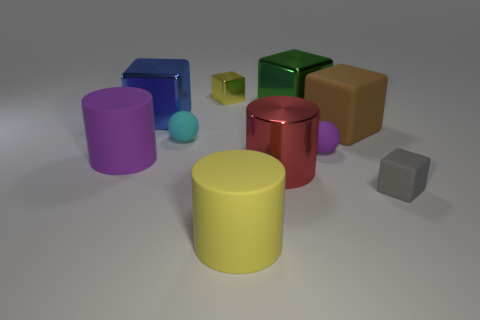What shape is the big metallic thing on the left side of the small cyan rubber thing that is behind the purple matte thing on the left side of the tiny cyan rubber thing?
Give a very brief answer. Cube. There is a yellow shiny thing that is the same size as the gray matte thing; what shape is it?
Offer a very short reply. Cube. There is a large thing that is the same color as the tiny shiny thing; what is its material?
Provide a short and direct response. Rubber. Are there any large purple matte cylinders behind the large blue metallic thing?
Your answer should be very brief. No. Is there a big red object that has the same shape as the tiny shiny object?
Your response must be concise. No. There is a small thing that is behind the blue shiny cube; is it the same shape as the purple thing right of the purple matte cylinder?
Your response must be concise. No. Is there a brown matte object that has the same size as the red thing?
Your answer should be compact. Yes. Are there the same number of gray rubber objects that are behind the large purple rubber cylinder and purple rubber things behind the brown block?
Keep it short and to the point. Yes. Are the big block on the left side of the large yellow matte cylinder and the yellow thing behind the large purple matte cylinder made of the same material?
Provide a succinct answer. Yes. What is the purple cylinder made of?
Your answer should be very brief. Rubber. 